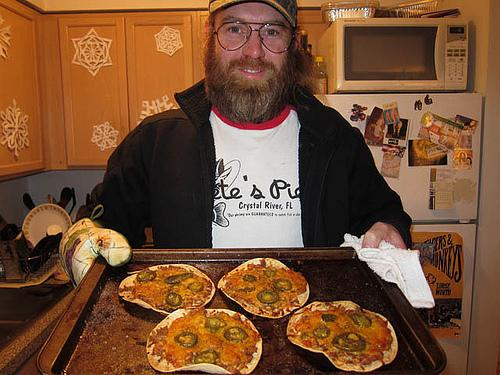How can you tell that this guy likes his food a little spicy? jalapenos 